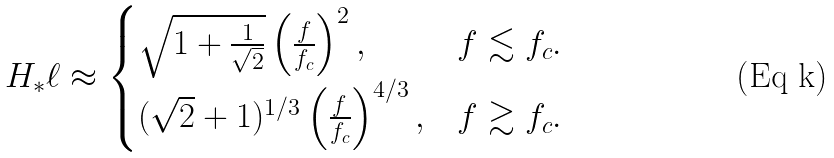Convert formula to latex. <formula><loc_0><loc_0><loc_500><loc_500>H _ { * } \ell \approx \begin{cases} \sqrt { 1 + \frac { 1 } { \sqrt { 2 } } } \left ( \frac { f } { f _ { c } } \right ) ^ { 2 } , & f \lesssim f _ { c } . \\ ( \sqrt { 2 } + 1 ) ^ { 1 / 3 } \left ( \frac { f } { f _ { c } } \right ) ^ { 4 / 3 } , & f \gtrsim f _ { c } . \end{cases}</formula> 